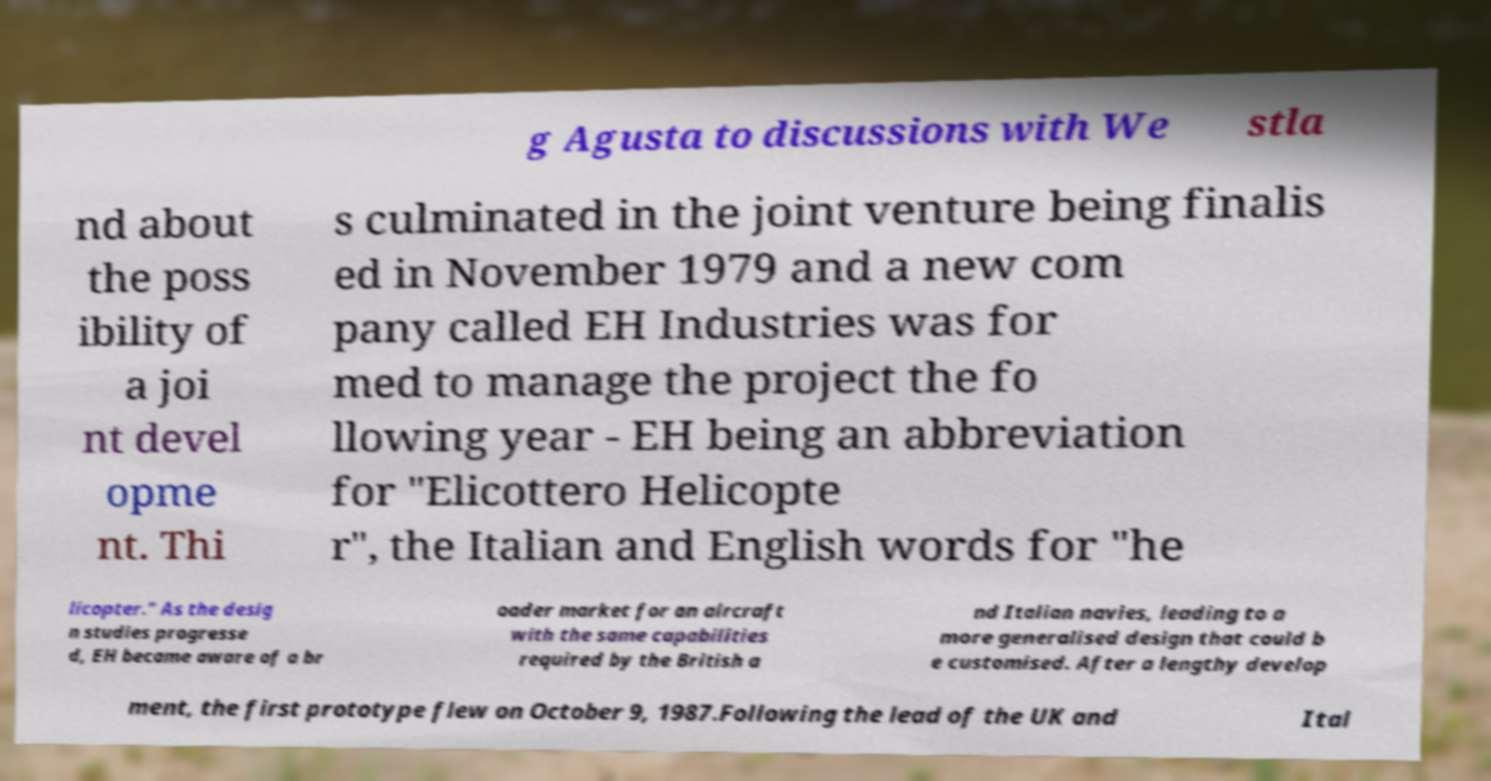Can you accurately transcribe the text from the provided image for me? g Agusta to discussions with We stla nd about the poss ibility of a joi nt devel opme nt. Thi s culminated in the joint venture being finalis ed in November 1979 and a new com pany called EH Industries was for med to manage the project the fo llowing year - EH being an abbreviation for "Elicottero Helicopte r", the Italian and English words for "he licopter." As the desig n studies progresse d, EH became aware of a br oader market for an aircraft with the same capabilities required by the British a nd Italian navies, leading to a more generalised design that could b e customised. After a lengthy develop ment, the first prototype flew on October 9, 1987.Following the lead of the UK and Ital 